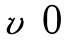<formula> <loc_0><loc_0><loc_500><loc_500>\begin{matrix} v & 0 \end{matrix}</formula> 